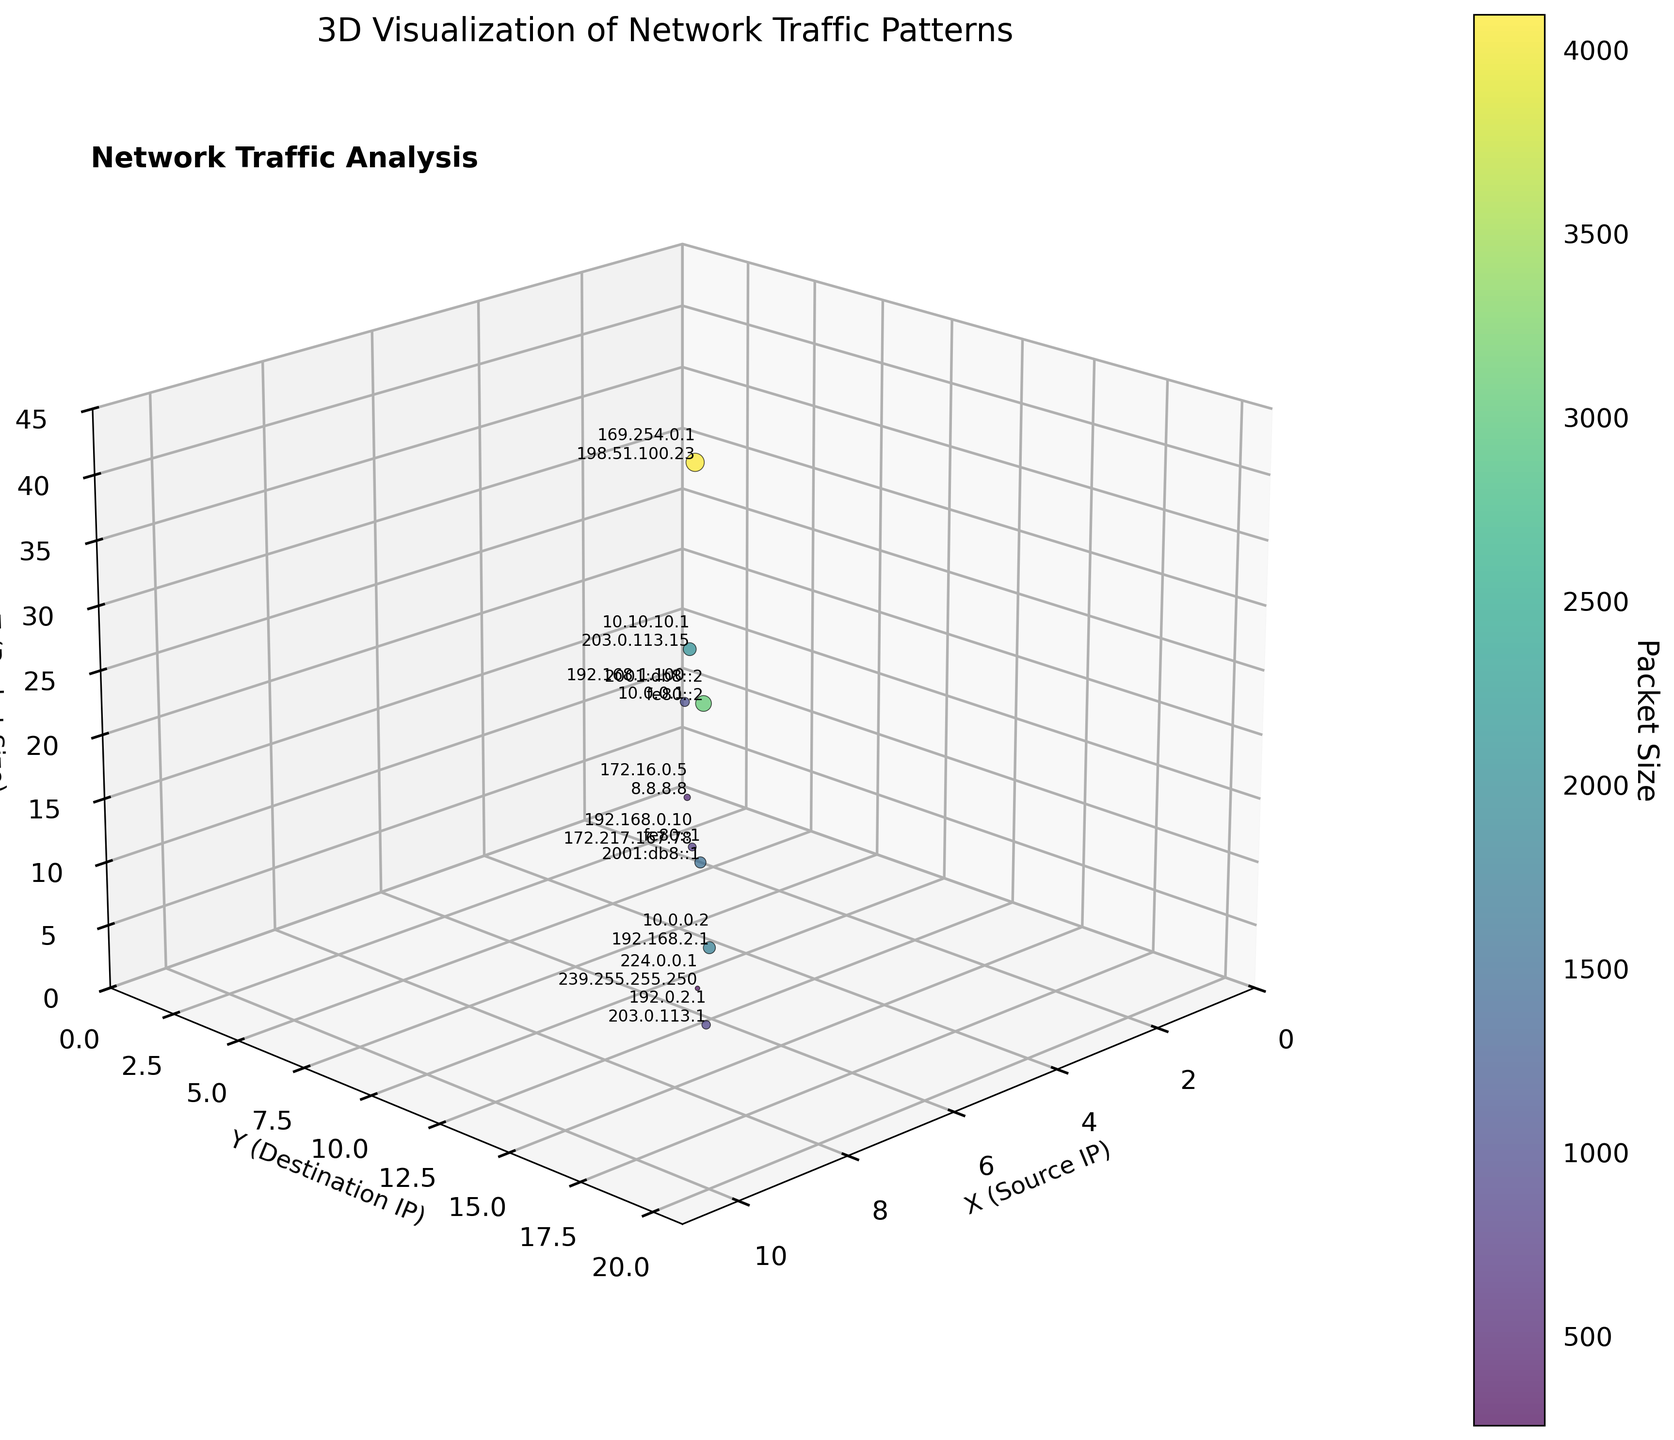what is the title of the plot? The title is written at the top of the plot denoting the main focus of the visualization.
Answer: 3D Visualization of Network Traffic Patterns What does the color bar represent? The color bar on the right side of the plot indicates the range values for packet size, helping differentiate data points based on packet sizes.
Answer: Packet Size How many data points are visualized in the plot? Each data point corresponds to a set of values from the dataset. By counting them, we find the number of visualized points.
Answer: 10 Which axis represents the destination IPs? The y-axis label mentions "Destination IP," providing clear identification.
Answer: y-axis What is the color of the point with the largest packet size? The point's color can be found by checking for the maximum packet size (4096), then identifying the corresponding color from the color bar.
Answer: Dark green What is the smallest packet size shown in the plot? By observing the color bar and data points, the smallest packet size (256) is found.
Answer: 256 Which data points have packet sizes greater than 3000 but less than 3100? We visually inspect the data points whose packet sizes fall within the specified range from the color bar.
Answer: (5,10,40) and (8,16,30) What is the relative position of the point with the source IP "192.0.2.1"? By locating the specified source IP and noting its (x,y,z) coordinates on the plot,
Answer: (9, 18, 9) What is the average packet size of all the data points? Sum all packet sizes and divide by the number of data points: (1024+512+2048+768+4096+256+1536+3072+896+1792)/10 = 14000/10
Answer: 1400 Between which marks did the highest point appear on the z-axis? By locating the point with the highest value (4096) on the z-axis, the range between two tick marks is found.
Answer: 30-40 